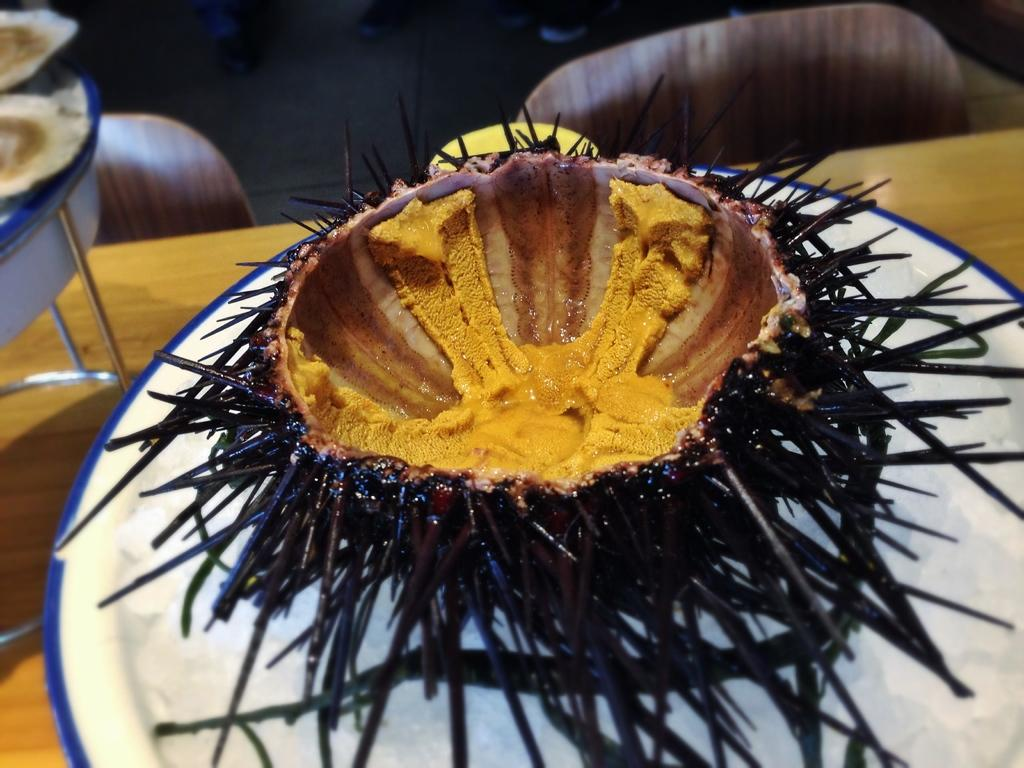What is the main subject of the image? There is a food item in the image. How is the food item presented? The food item is placed on a plate. Where is the plate located? The plate is placed on a table. How does the honey rest on the wrist in the image? There is no honey or wrist present in the image. 